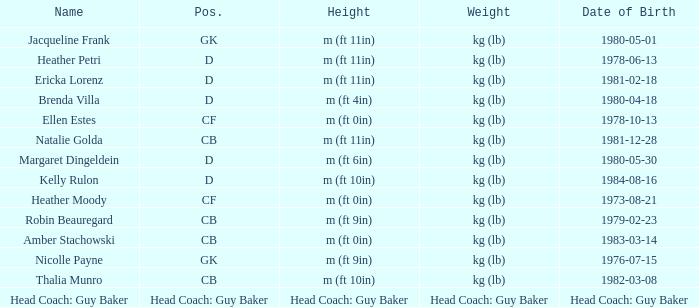What is the name of the individual with the initials cf, born on the 21st of august in 1973? Heather Moody. 